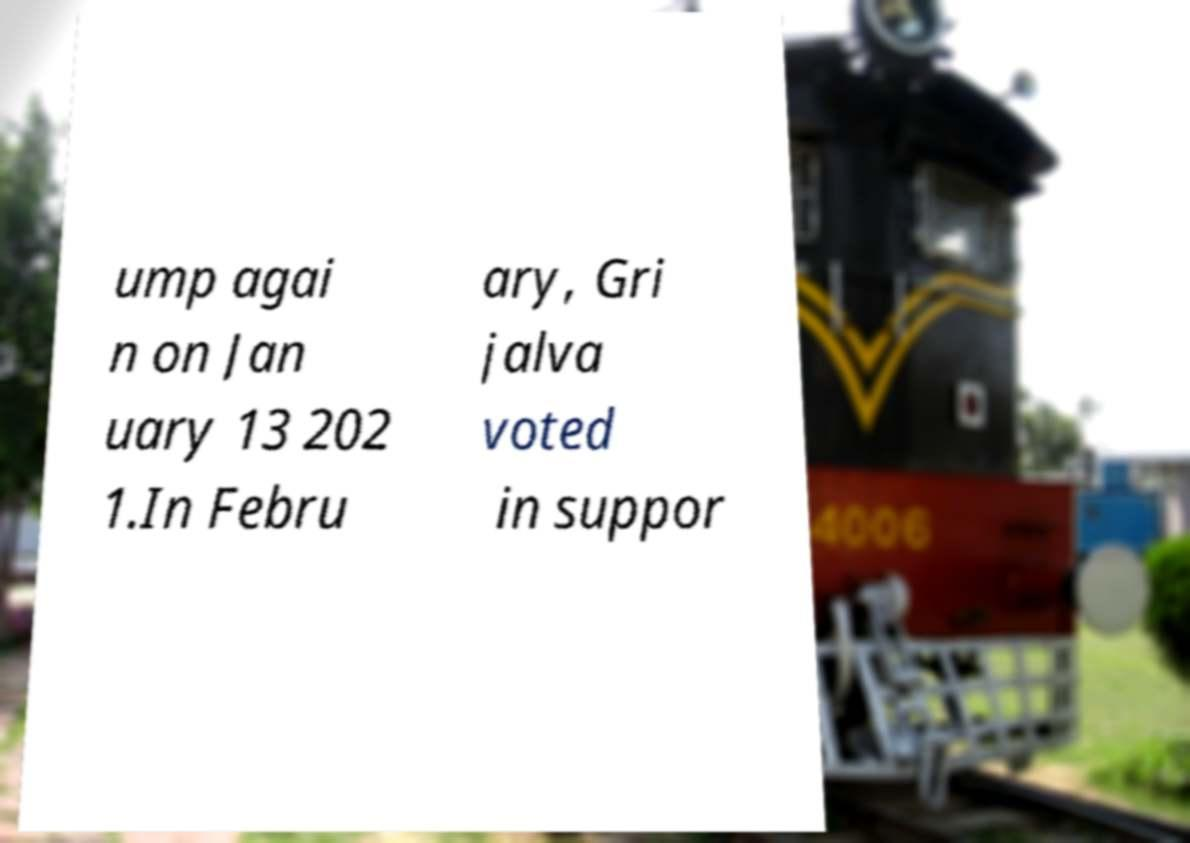Can you read and provide the text displayed in the image?This photo seems to have some interesting text. Can you extract and type it out for me? ump agai n on Jan uary 13 202 1.In Febru ary, Gri jalva voted in suppor 